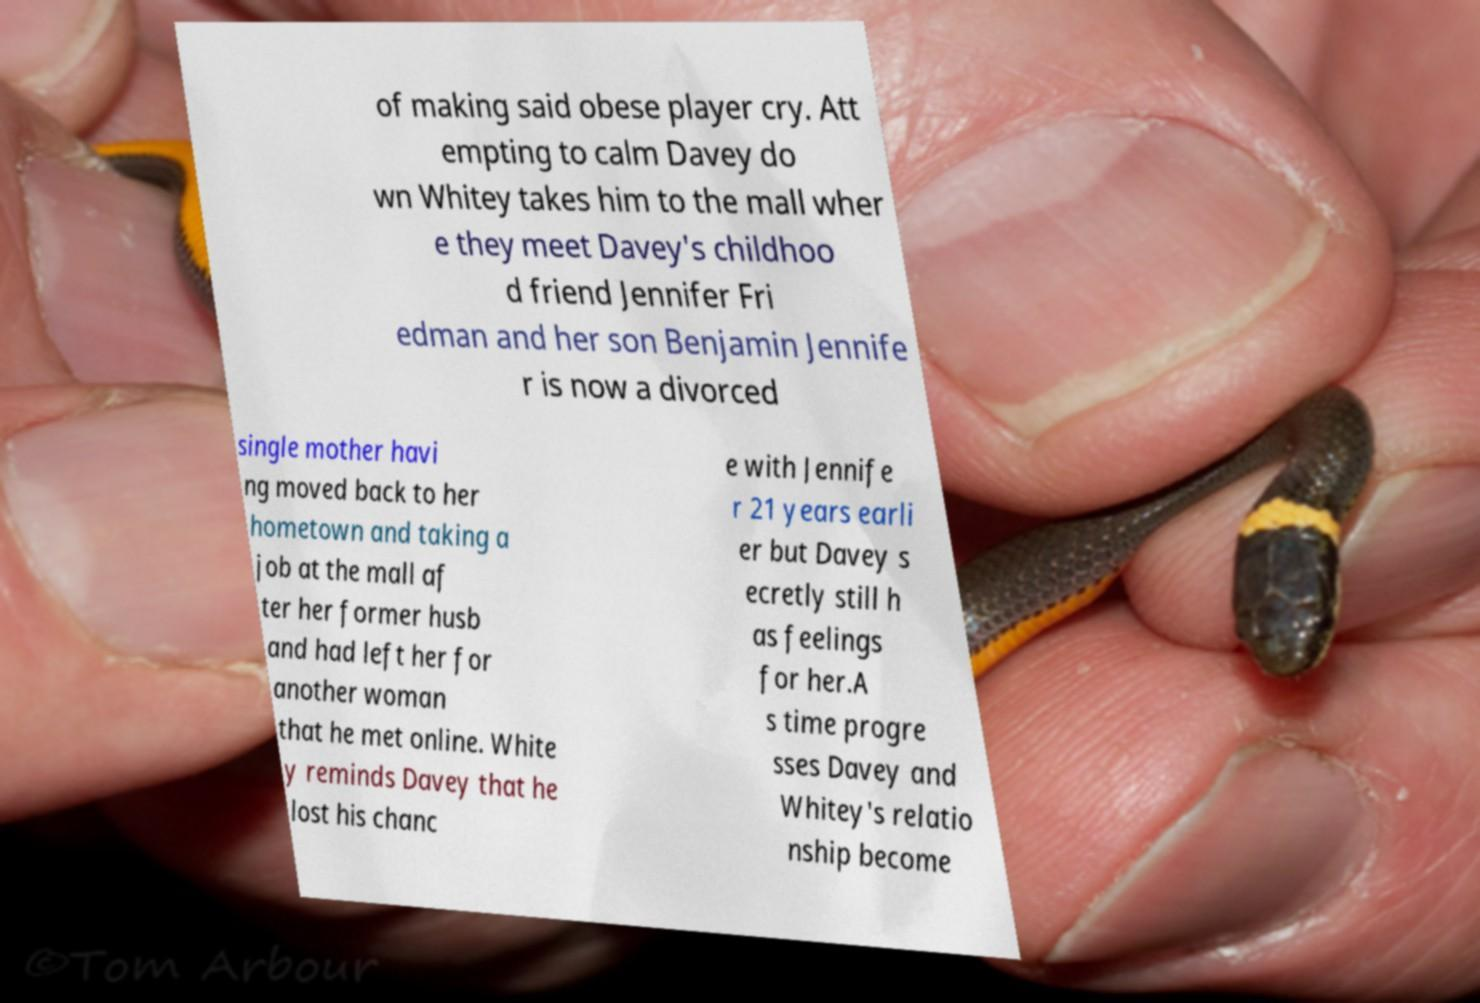Can you accurately transcribe the text from the provided image for me? of making said obese player cry. Att empting to calm Davey do wn Whitey takes him to the mall wher e they meet Davey's childhoo d friend Jennifer Fri edman and her son Benjamin Jennife r is now a divorced single mother havi ng moved back to her hometown and taking a job at the mall af ter her former husb and had left her for another woman that he met online. White y reminds Davey that he lost his chanc e with Jennife r 21 years earli er but Davey s ecretly still h as feelings for her.A s time progre sses Davey and Whitey's relatio nship become 